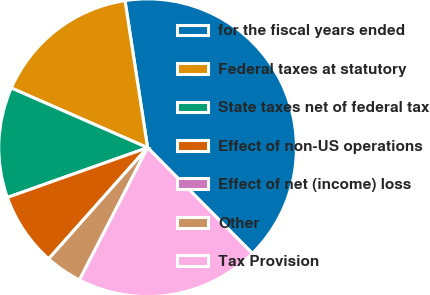<chart> <loc_0><loc_0><loc_500><loc_500><pie_chart><fcel>for the fiscal years ended<fcel>Federal taxes at statutory<fcel>State taxes net of federal tax<fcel>Effect of non-US operations<fcel>Effect of net (income) loss<fcel>Other<fcel>Tax Provision<nl><fcel>40.0%<fcel>16.0%<fcel>12.0%<fcel>8.0%<fcel>0.0%<fcel>4.0%<fcel>20.0%<nl></chart> 